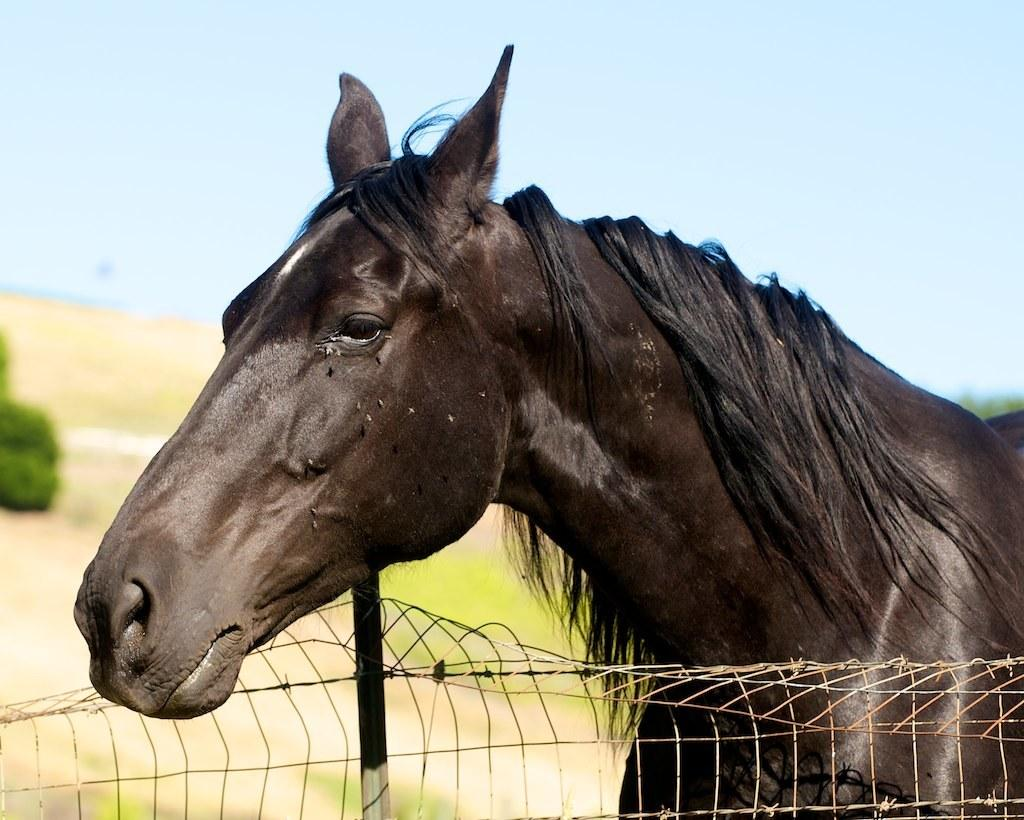What type of animal is in the image? There is a black horse in the image. What is present in the image that might be used for containing or separating areas? There is fencing in the image. What type of vegetation can be seen in the image? There are plants in the image. What part of the natural environment is visible in the image? The sky is visible in the image. How would you describe the background of the image? The background of the image is blurred. How does the bun increase in size in the image? There is no bun present in the image, so it cannot increase in size. 